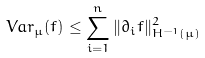<formula> <loc_0><loc_0><loc_500><loc_500>V a r _ { \mu } ( f ) \leq \sum _ { i = 1 } ^ { n } \| \partial _ { i } f \| ^ { 2 } _ { H ^ { - 1 } ( \mu ) }</formula> 